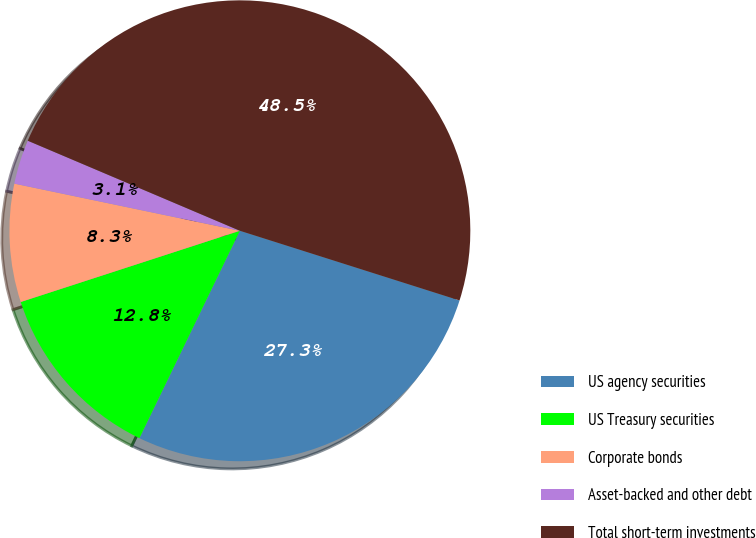Convert chart. <chart><loc_0><loc_0><loc_500><loc_500><pie_chart><fcel>US agency securities<fcel>US Treasury securities<fcel>Corporate bonds<fcel>Asset-backed and other debt<fcel>Total short-term investments<nl><fcel>27.29%<fcel>12.82%<fcel>8.28%<fcel>3.11%<fcel>48.5%<nl></chart> 